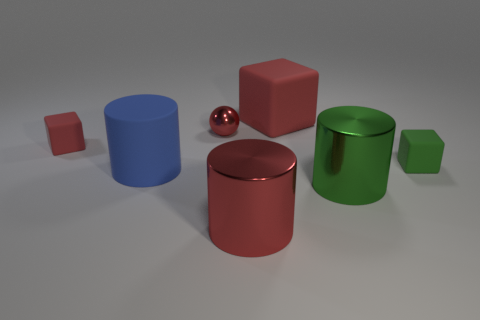Does the green cylinder have the same material as the blue object?
Your response must be concise. No. What is the material of the small red object that is on the right side of the small matte cube that is behind the tiny green rubber object?
Ensure brevity in your answer.  Metal. There is a red block left of the small red shiny thing; what size is it?
Your answer should be compact. Small. Do the red matte block in front of the red shiny ball and the large green metallic object have the same size?
Your answer should be very brief. No. What material is the tiny sphere?
Keep it short and to the point. Metal. What is the size of the green matte thing that is the same shape as the tiny red matte thing?
Provide a short and direct response. Small. There is a red cylinder on the left side of the large red matte object; what material is it?
Ensure brevity in your answer.  Metal. What number of cylinders have the same color as the small shiny ball?
Provide a succinct answer. 1. There is a red cylinder; does it have the same size as the cylinder that is behind the big green shiny cylinder?
Offer a very short reply. Yes. What is the size of the red ball?
Your answer should be compact. Small. 